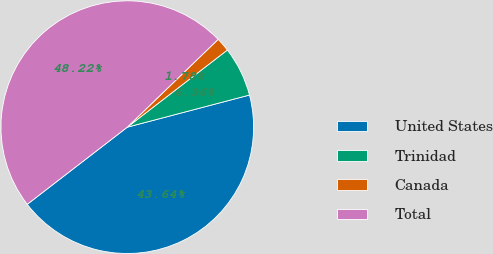<chart> <loc_0><loc_0><loc_500><loc_500><pie_chart><fcel>United States<fcel>Trinidad<fcel>Canada<fcel>Total<nl><fcel>43.64%<fcel>6.36%<fcel>1.78%<fcel>48.22%<nl></chart> 